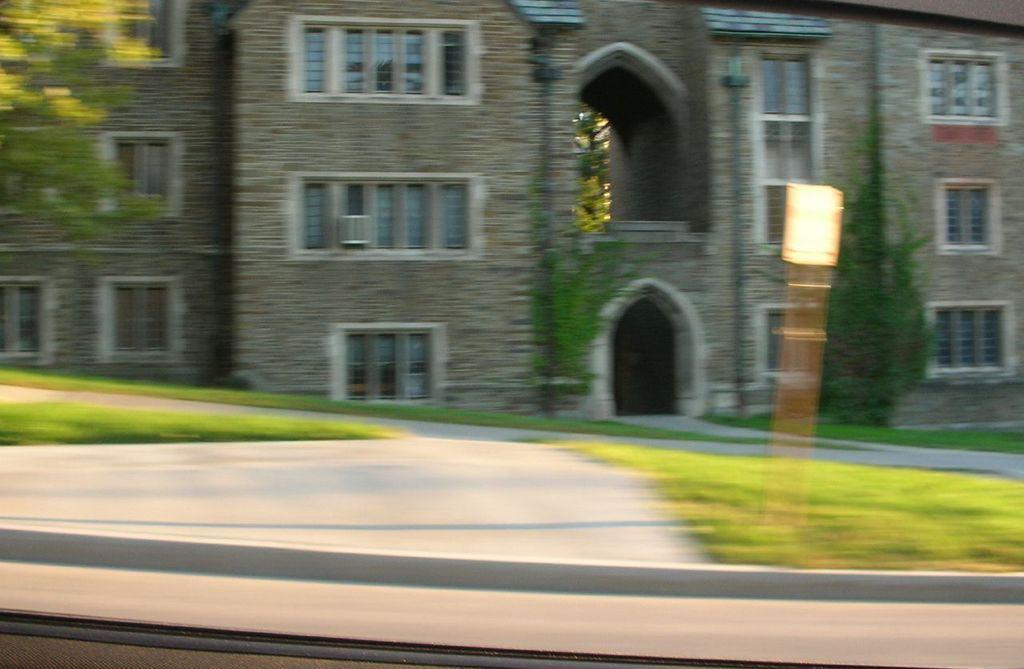How would you summarize this image in a sentence or two? In the picture we can see a building with windows and near it, we can see some plants and the path and both the sides of the path we can see the grass surface. 